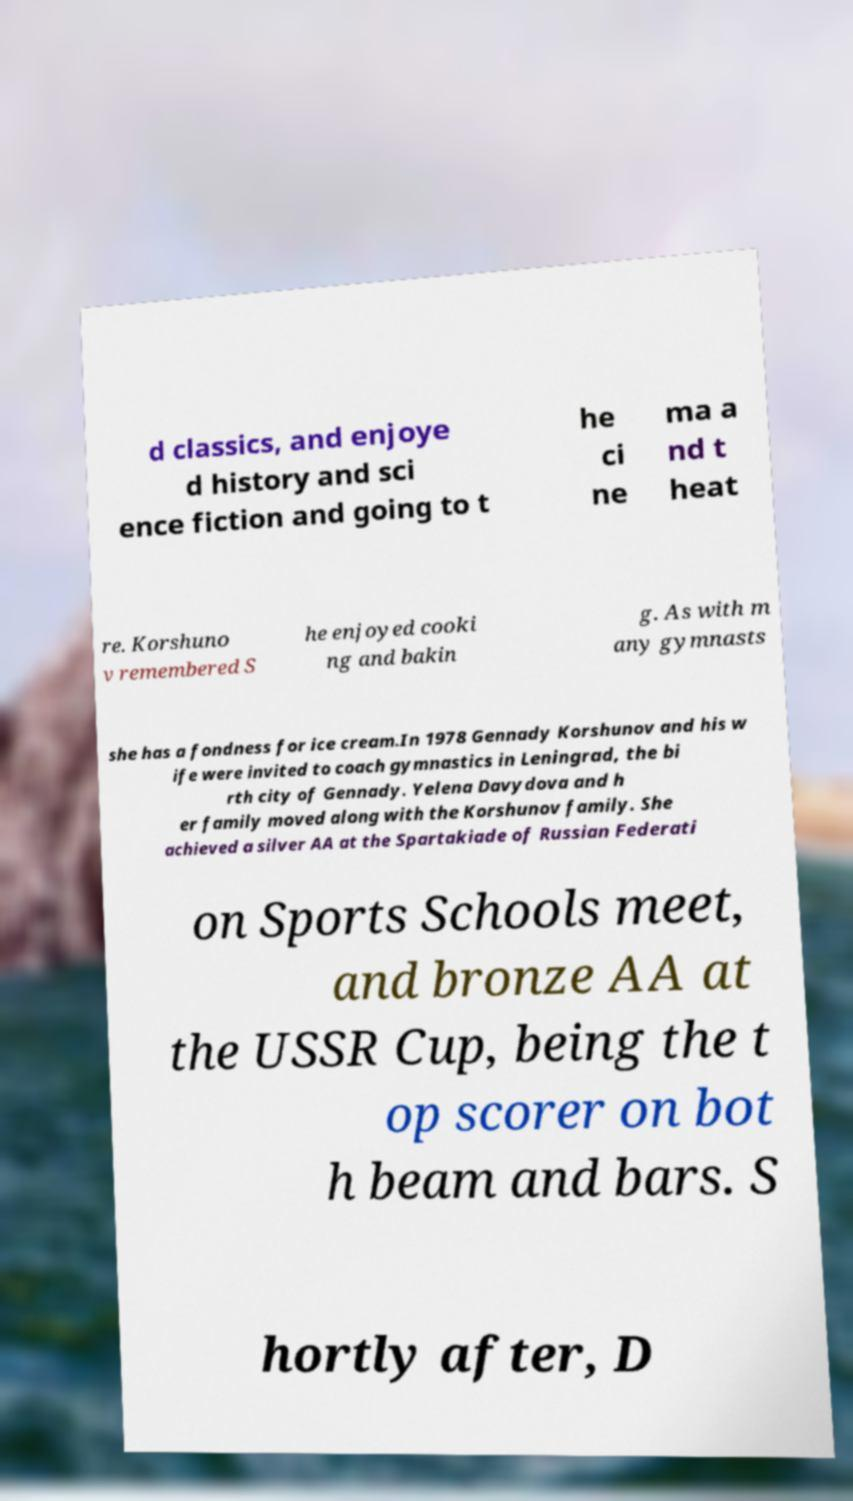Could you extract and type out the text from this image? d classics, and enjoye d history and sci ence fiction and going to t he ci ne ma a nd t heat re. Korshuno v remembered S he enjoyed cooki ng and bakin g. As with m any gymnasts she has a fondness for ice cream.In 1978 Gennady Korshunov and his w ife were invited to coach gymnastics in Leningrad, the bi rth city of Gennady. Yelena Davydova and h er family moved along with the Korshunov family. She achieved a silver AA at the Spartakiade of Russian Federati on Sports Schools meet, and bronze AA at the USSR Cup, being the t op scorer on bot h beam and bars. S hortly after, D 